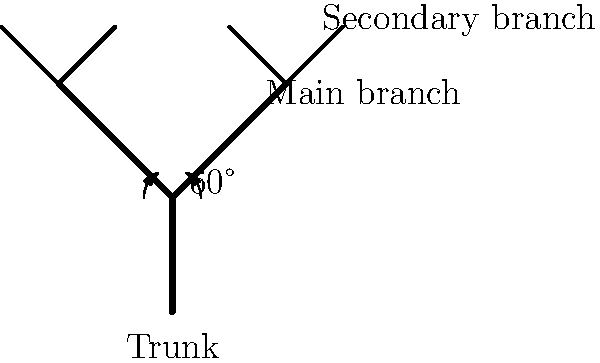In pruning fruit trees, what is the optimal angle between the main branches and the trunk to promote healthy growth and fruit production? Use the diagram to determine the angle and explain its benefits. To determine the optimal angle for pruning fruit trees, we need to consider several factors:

1. Branch strength: The angle between the main branches and the trunk affects the structural integrity of the tree.

2. Sunlight exposure: Proper branching angles allow for better light penetration throughout the canopy.

3. Nutrient distribution: The angle influences the distribution of nutrients and water within the tree.

4. Fruit production: Optimal branching angles can lead to increased fruit yield and quality.

In the diagram, we can see that the main branches are positioned at a 60° angle from the trunk. This angle is generally considered optimal for fruit trees because:

a) It provides a strong structural connection between the branch and the trunk, reducing the risk of breakage under the weight of fruit or during storms.

b) It allows for maximum sunlight exposure to both the main branches and secondary branches, promoting photosynthesis and fruit development.

c) The 60° angle facilitates efficient nutrient and water transport from the roots to the branches and fruits.

d) This angle promotes the development of fruit spurs along the branches, leading to increased fruit production.

e) It allows for proper air circulation within the tree canopy, reducing the risk of fungal diseases.

By maintaining this optimal angle during pruning, gardeners can encourage healthy growth patterns and maximize fruit production in their fruit trees.
Answer: 60° 